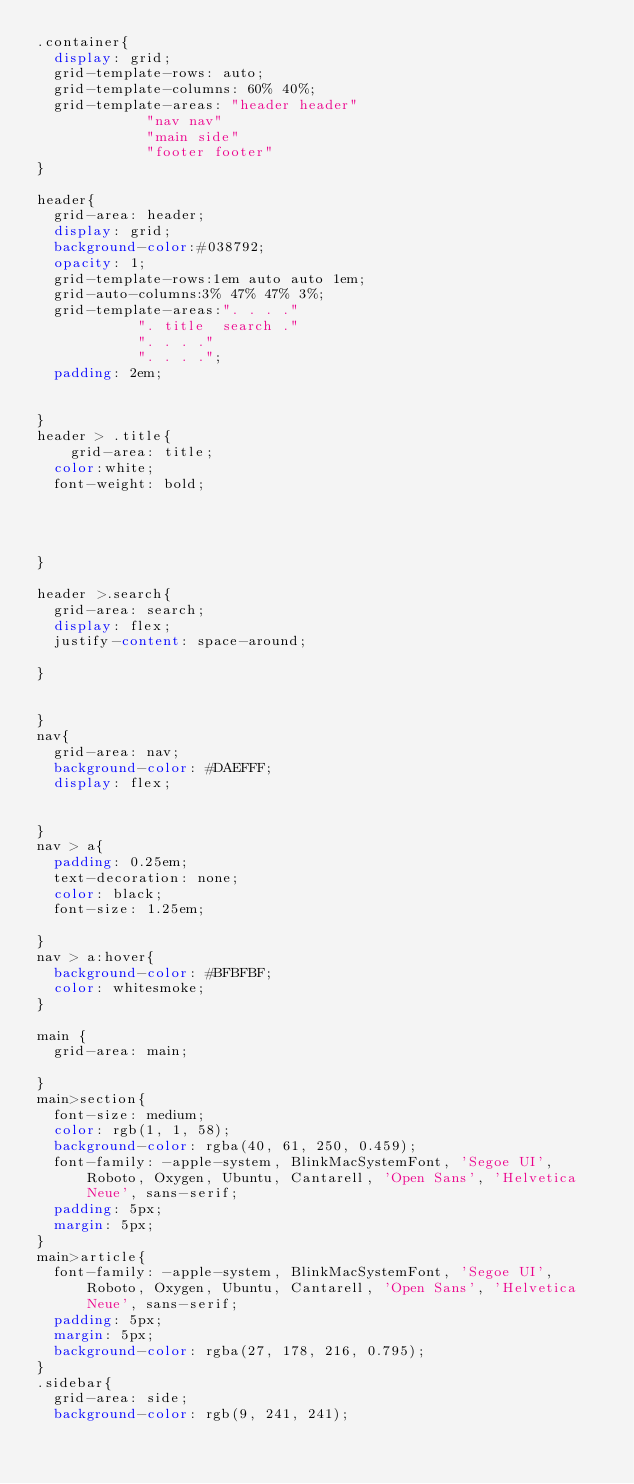<code> <loc_0><loc_0><loc_500><loc_500><_CSS_>.container{
	display: grid;
	grid-template-rows: auto;
	grid-template-columns: 60% 40%;
	grid-template-areas: "header header"
						 "nav nav"
						 "main side"
						 "footer footer"
}

header{
	grid-area: header;
	display: grid;
	background-color:#038792;
	opacity: 1;
	grid-template-rows:1em auto auto 1em;
	grid-auto-columns:3% 47% 47% 3%;
	grid-template-areas:". . . ."
						". title  search ."
						". . . ."
						". . . .";
	padding: 2em;
	
	
}
header > .title{
    grid-area: title;
	color:white;
	font-weight: bold;

    

	
}

header >.search{
	grid-area: search;
	display: flex;
	justify-content: space-around;
	
}


}
nav{
	grid-area: nav;
	background-color: #DAEFFF;
	display: flex;

	
}
nav > a{
	padding: 0.25em;
	text-decoration: none;
	color: black;
	font-size: 1.25em;
	
}
nav > a:hover{
	background-color: #BFBFBF;
	color: whitesmoke;
}

main {
	grid-area: main;
	
}
main>section{
	font-size: medium;
	color: rgb(1, 1, 58);
	background-color: rgba(40, 61, 250, 0.459);
	font-family: -apple-system, BlinkMacSystemFont, 'Segoe UI', Roboto, Oxygen, Ubuntu, Cantarell, 'Open Sans', 'Helvetica Neue', sans-serif;
	padding: 5px;
	margin: 5px;
}
main>article{
	font-family: -apple-system, BlinkMacSystemFont, 'Segoe UI', Roboto, Oxygen, Ubuntu, Cantarell, 'Open Sans', 'Helvetica Neue', sans-serif;
	padding: 5px;
	margin: 5px;
	background-color: rgba(27, 178, 216, 0.795);
}
.sidebar{
	grid-area: side;
	background-color: rgb(9, 241, 241);</code> 